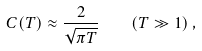<formula> <loc_0><loc_0><loc_500><loc_500>C ( T ) \approx \frac { 2 } { \sqrt { \pi T } } \quad ( T \gg 1 ) \, ,</formula> 